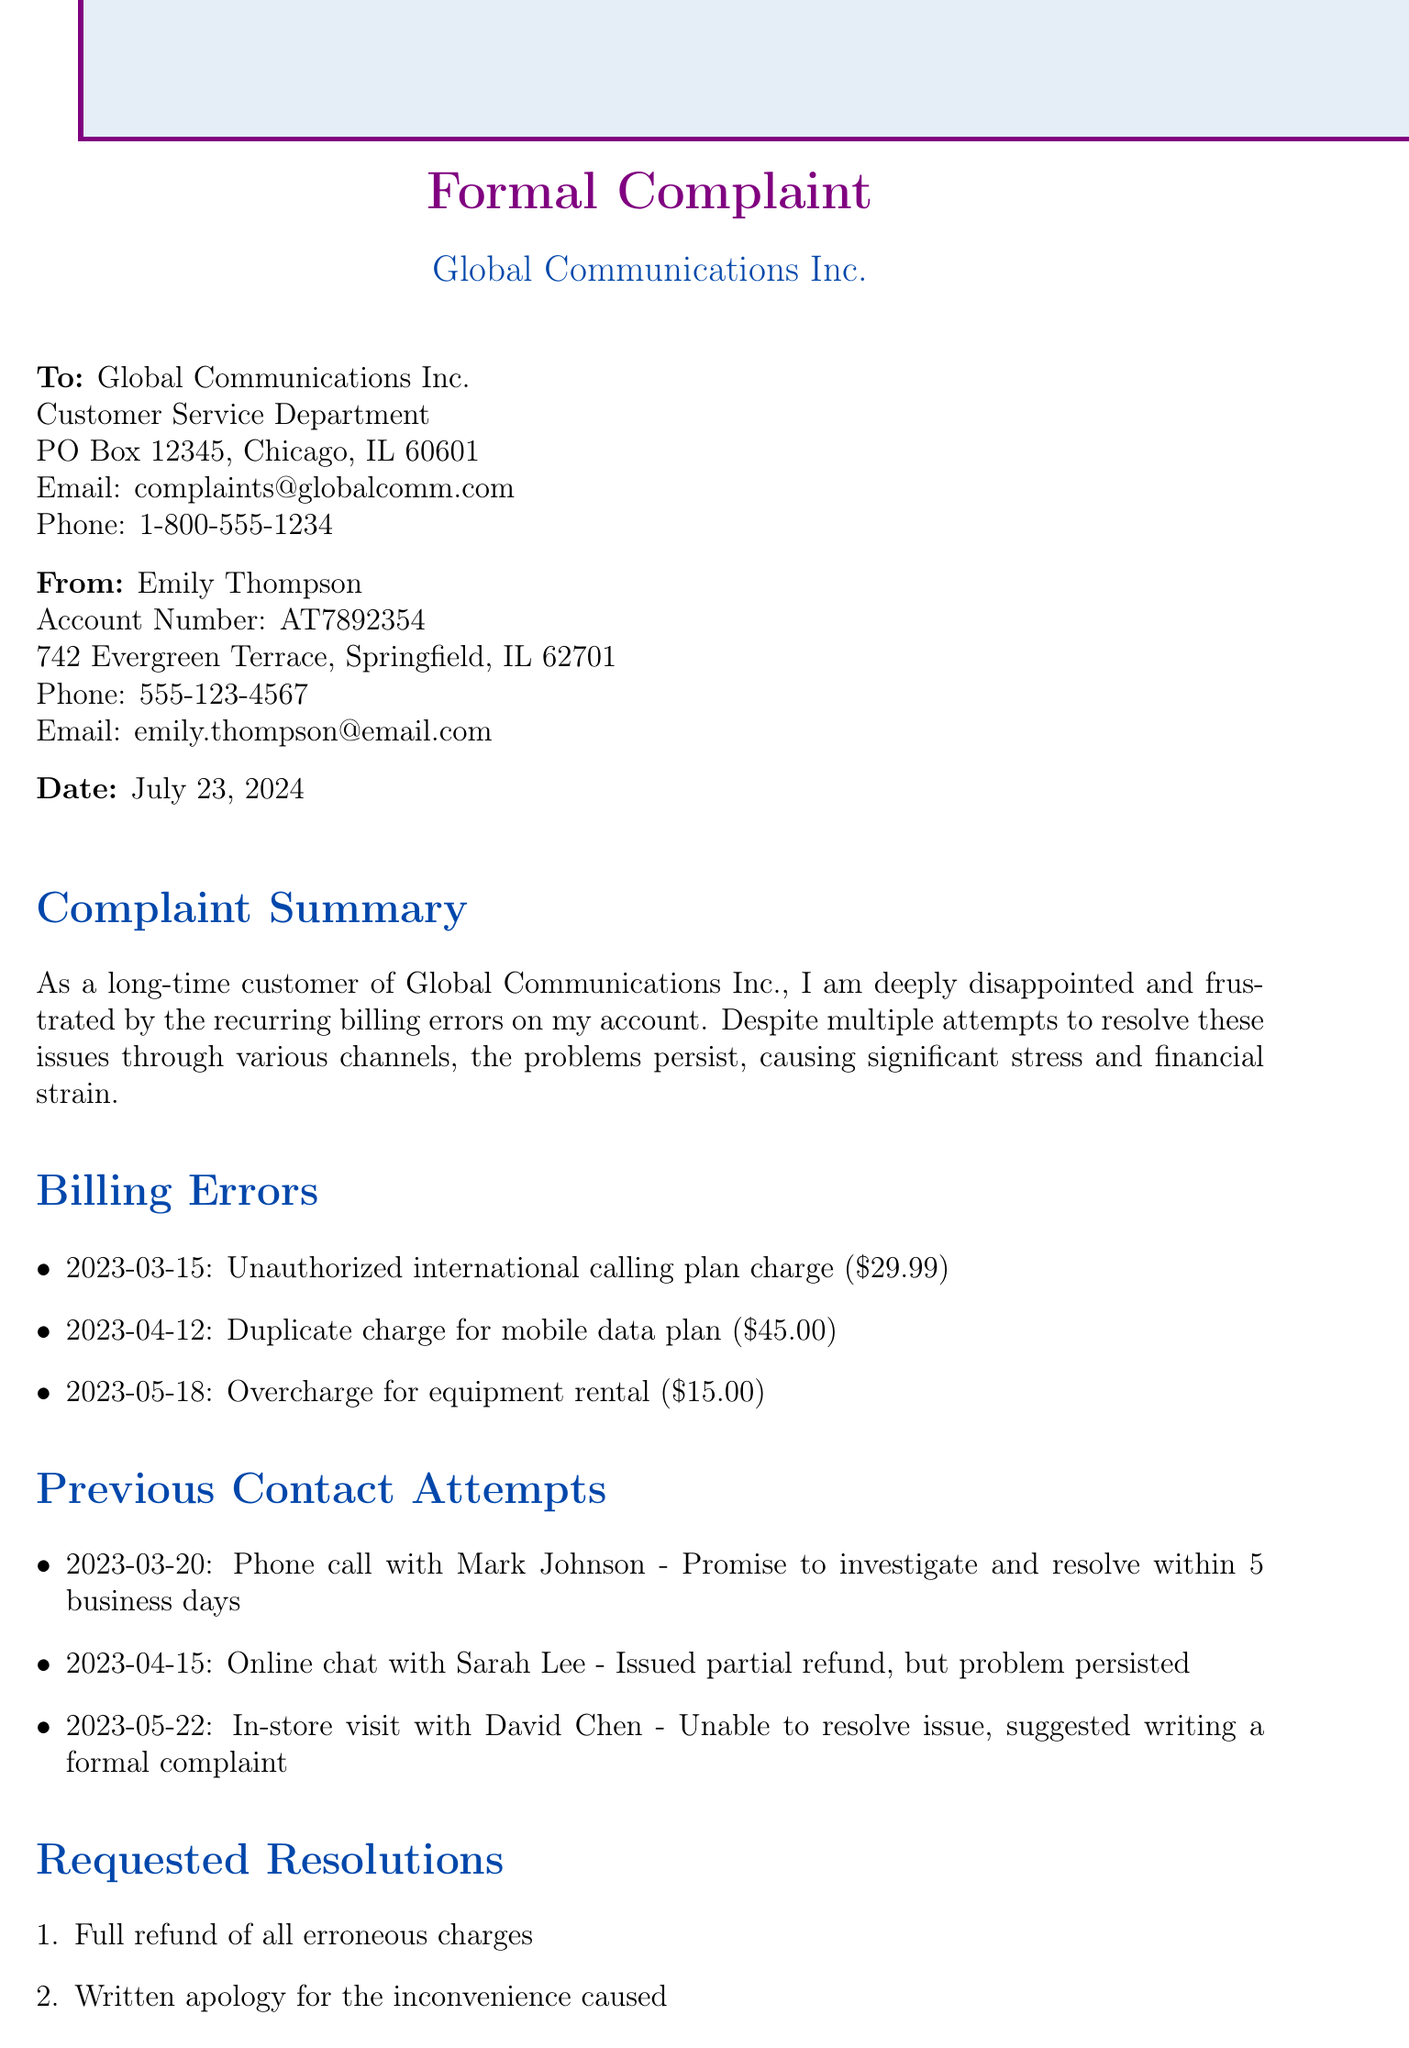What is the customer's name? The customer's name is mentioned in the document as the person filing the complaint.
Answer: Emily Thompson What is the account number? The account number is specified in the customer information section of the document.
Answer: AT7892354 What was charged on March 15, 2023? This date refers to a specific billing error and is detailed under the billing errors section.
Answer: Unauthorized international calling plan charge How much was the duplicate charge for the mobile data plan? The amount for the duplicate charge is listed specifically under the billing errors section.
Answer: $45.00 Who did Emily contact on April 15, 2023? The document provides information about the representative Emily spoke with during her contact attempt.
Answer: Sarah Lee What is one of the requested resolutions? The document outlines specific resolutions that the customer is seeking in response to her complaint.
Answer: Full refund of all erroneous charges How long has Emily been a customer of Global Communications Inc.? The duration of Emily's customer relationship with the company is mentioned in the closing statement.
Answer: Over five years What was the outcome of the in-store visit on May 22, 2023? The response details what happened during Emily's visit to the store, indicating the result of the interaction.
Answer: Unable to resolve issue, suggested writing a formal complaint What type of document is this? This document serves a specific purpose related to customer grievances within the telecommunications sector.
Answer: Formal Complaint What was Emily's email address? The email address of the customer is provided in the customer information section of the document.
Answer: emily.thompson@email.com 